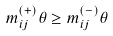<formula> <loc_0><loc_0><loc_500><loc_500>m _ { i j } ^ { ( + ) } \theta \geq m _ { i j } ^ { ( - ) } \theta</formula> 